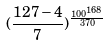<formula> <loc_0><loc_0><loc_500><loc_500>( \frac { 1 2 7 - 4 } { 7 } ) ^ { \frac { 1 0 0 ^ { 1 6 8 } } { 3 7 0 } }</formula> 